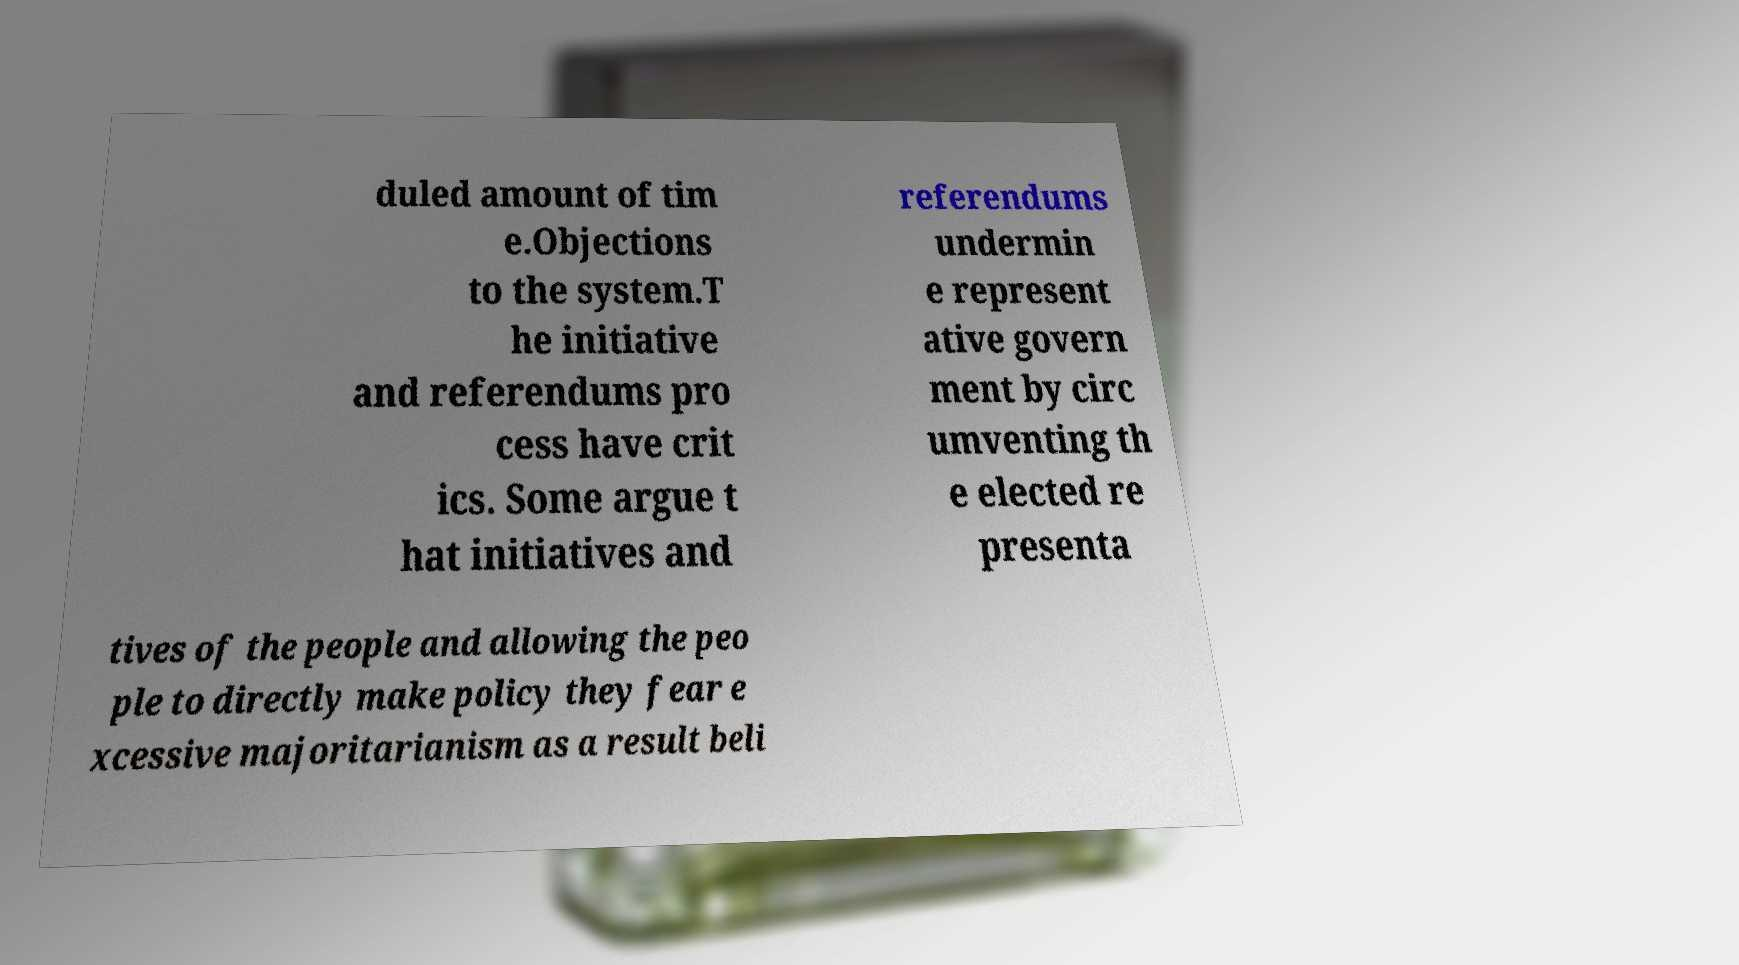Please identify and transcribe the text found in this image. duled amount of tim e.Objections to the system.T he initiative and referendums pro cess have crit ics. Some argue t hat initiatives and referendums undermin e represent ative govern ment by circ umventing th e elected re presenta tives of the people and allowing the peo ple to directly make policy they fear e xcessive majoritarianism as a result beli 